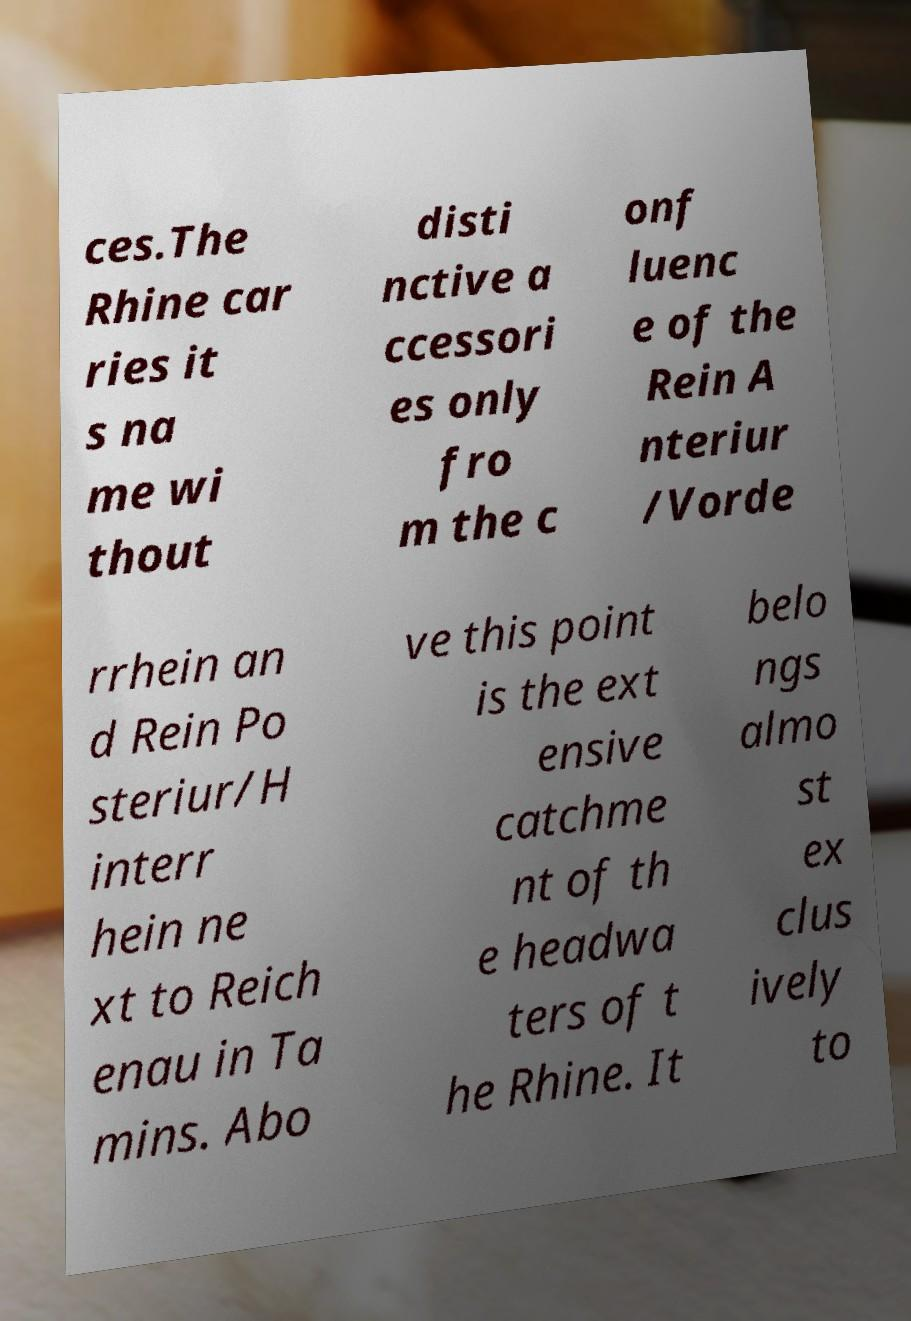Can you accurately transcribe the text from the provided image for me? ces.The Rhine car ries it s na me wi thout disti nctive a ccessori es only fro m the c onf luenc e of the Rein A nteriur /Vorde rrhein an d Rein Po steriur/H interr hein ne xt to Reich enau in Ta mins. Abo ve this point is the ext ensive catchme nt of th e headwa ters of t he Rhine. It belo ngs almo st ex clus ively to 